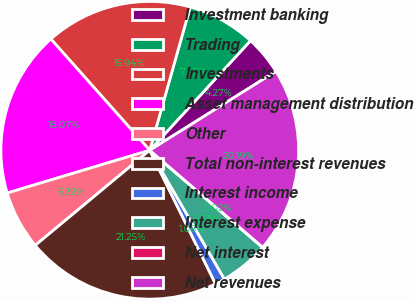Convert chart. <chart><loc_0><loc_0><loc_500><loc_500><pie_chart><fcel>Investment banking<fcel>Trading<fcel>Investments<fcel>Asset management distribution<fcel>Other<fcel>Total non-interest revenues<fcel>Interest income<fcel>Interest expense<fcel>Net interest<fcel>Net revenues<nl><fcel>4.27%<fcel>7.45%<fcel>15.94%<fcel>18.07%<fcel>6.39%<fcel>21.25%<fcel>1.08%<fcel>5.33%<fcel>0.02%<fcel>20.19%<nl></chart> 